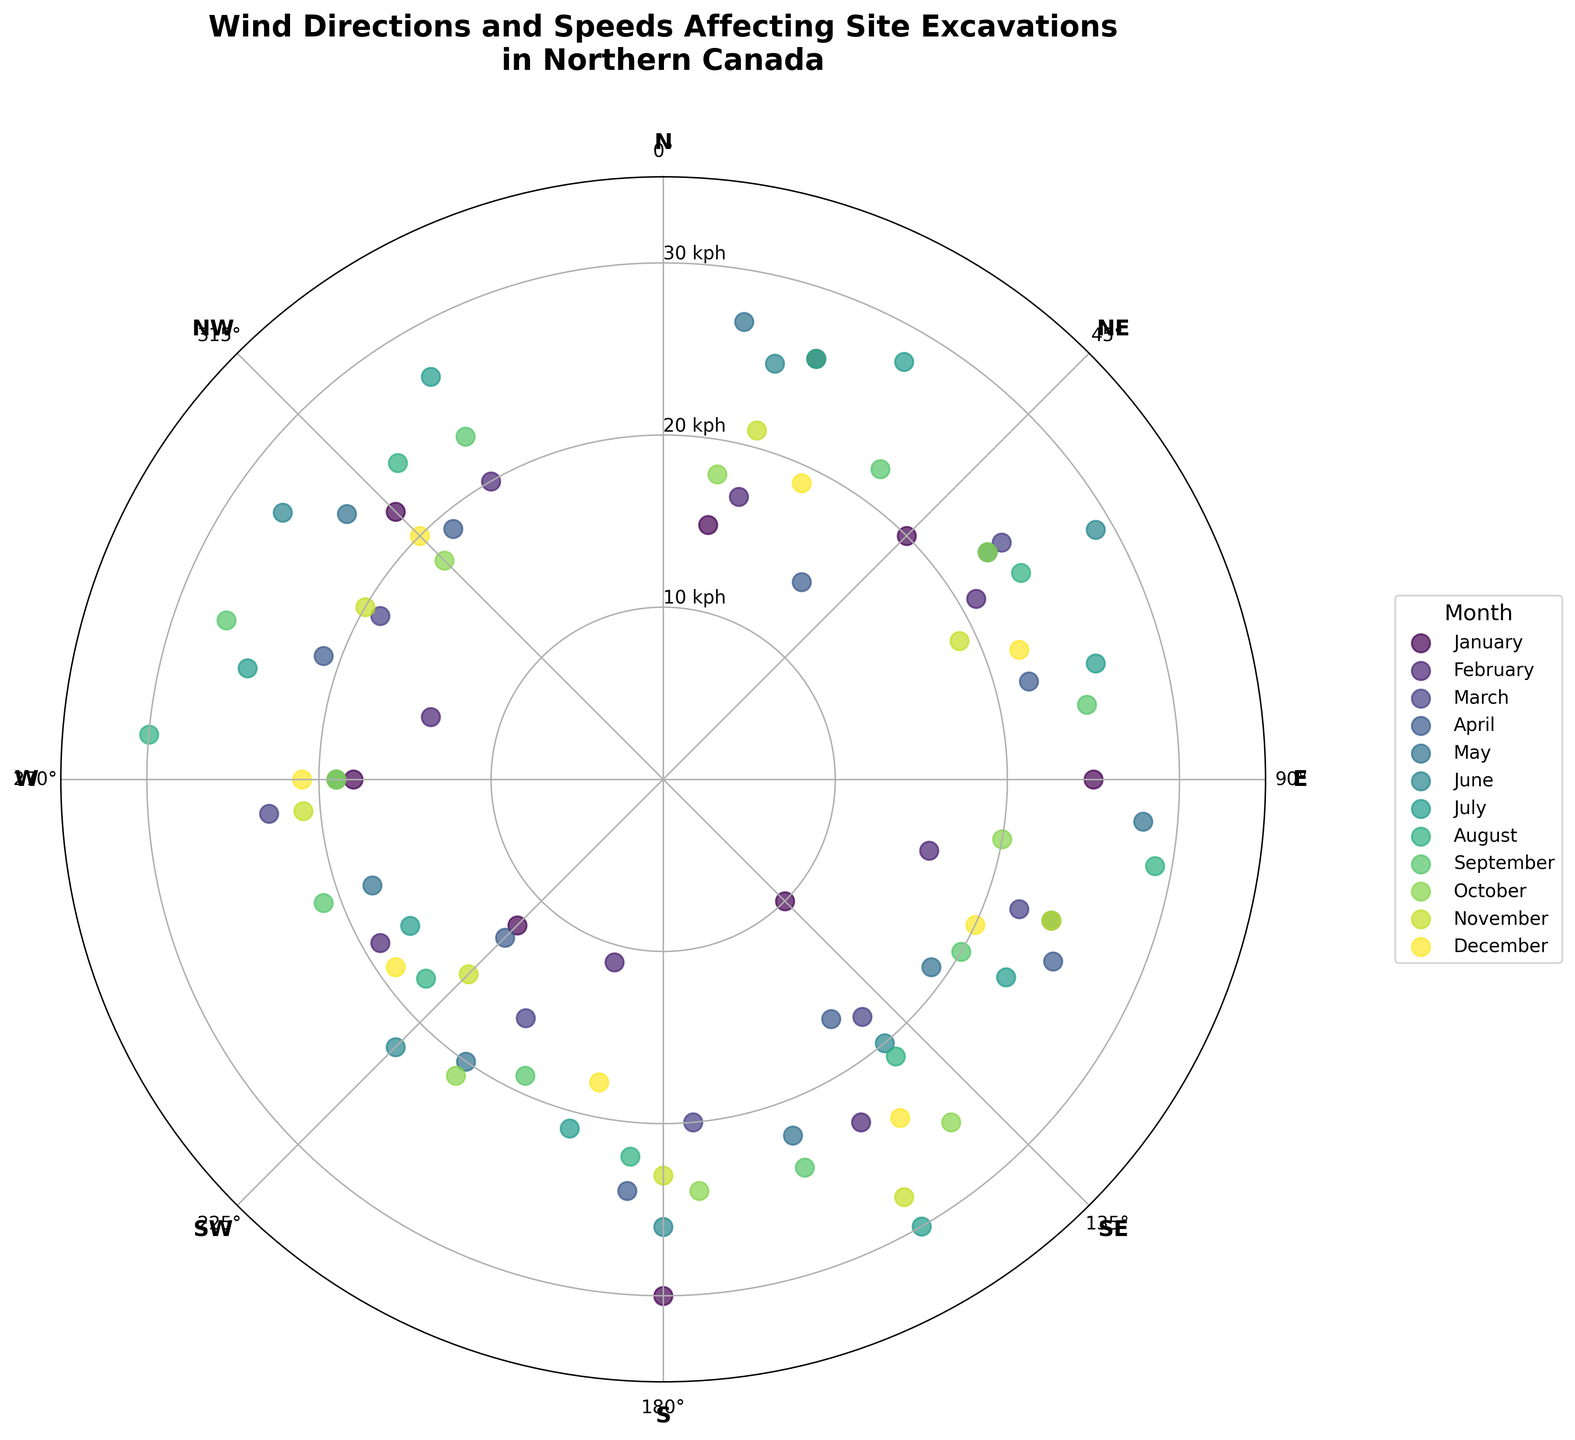Where is the peak wind speed in January located? To determine the peak wind speed for January, locate the January data points on the chart (marked by their specific color) and identify the one furthest from the center. Observing carefully, the point at 180 degrees shows the furthest mark from the center within January points, indicating the highest speed.
Answer: 180 degrees Which month has the highest peak wind speed? To identify this, look at the farthest points from the center across all months. The highest peak wind speed is represented by the point at 275 degrees in August, showing a speed of 30 kph.
Answer: August During which month is the wind generally directed between 0 and 90 degrees? Check the data points within 0 to 90 degrees for each month. Noting these points, January frequently falls within this directional range.
Answer: January How does the average wind speed for May compare to that of July? Identify the data points for May and July, calculate the average wind speeds for both, and compare. For May, the speeds are 27, 23, 28, 19, 22, 20, 18, 24 with an average of 22.6 kph. For July, the speeds are 28, 26, 23, 30, 21, 17, 25, 27 with an average of 24.6 kph.
Answer: July's average is higher What is the cardinal direction with the fewest data points? Analyze all the cardinal direction data (N, NE, E, SE, S, SW, W, NW) and count the occurrences. Observing carefully, North-West (NW) has the fewest data points.
Answer: North-West (NW) What is the overall range of wind speeds across all months? Identify the minimum and maximum wind speeds from the data. The lowest is 10 kph and the highest is 30 kph across all months. Hence, the range is the difference between them.
Answer: 20 kph Which month has the most consistent wind speeds? To determine this, consider the spread of points (cluster tightness) for each month. Observing carefully, December exhibits the most closely packed data points, indicating consistent speeds.
Answer: December 